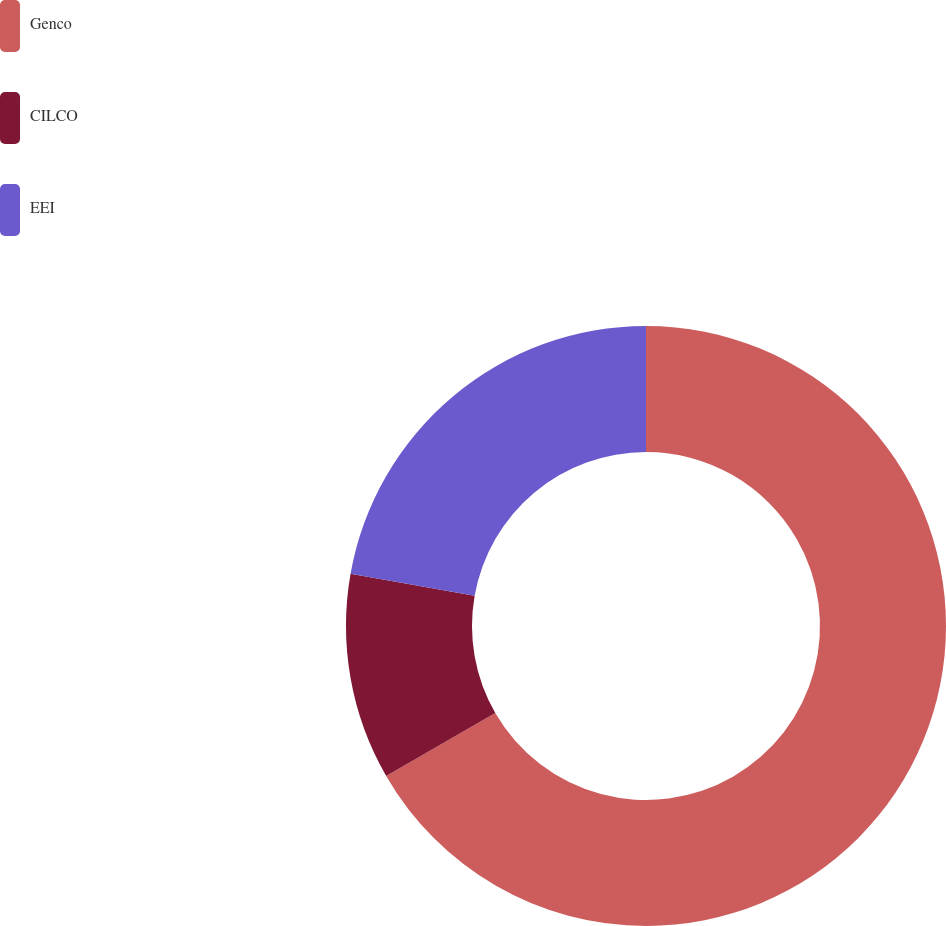<chart> <loc_0><loc_0><loc_500><loc_500><pie_chart><fcel>Genco<fcel>CILCO<fcel>EEI<nl><fcel>66.67%<fcel>11.11%<fcel>22.22%<nl></chart> 